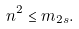<formula> <loc_0><loc_0><loc_500><loc_500>n ^ { 2 } \leq m _ { 2 s } .</formula> 